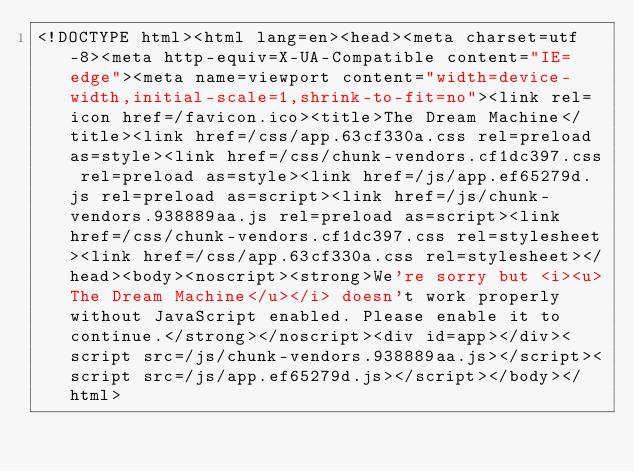<code> <loc_0><loc_0><loc_500><loc_500><_HTML_><!DOCTYPE html><html lang=en><head><meta charset=utf-8><meta http-equiv=X-UA-Compatible content="IE=edge"><meta name=viewport content="width=device-width,initial-scale=1,shrink-to-fit=no"><link rel=icon href=/favicon.ico><title>The Dream Machine</title><link href=/css/app.63cf330a.css rel=preload as=style><link href=/css/chunk-vendors.cf1dc397.css rel=preload as=style><link href=/js/app.ef65279d.js rel=preload as=script><link href=/js/chunk-vendors.938889aa.js rel=preload as=script><link href=/css/chunk-vendors.cf1dc397.css rel=stylesheet><link href=/css/app.63cf330a.css rel=stylesheet></head><body><noscript><strong>We're sorry but <i><u>The Dream Machine</u></i> doesn't work properly without JavaScript enabled. Please enable it to continue.</strong></noscript><div id=app></div><script src=/js/chunk-vendors.938889aa.js></script><script src=/js/app.ef65279d.js></script></body></html></code> 